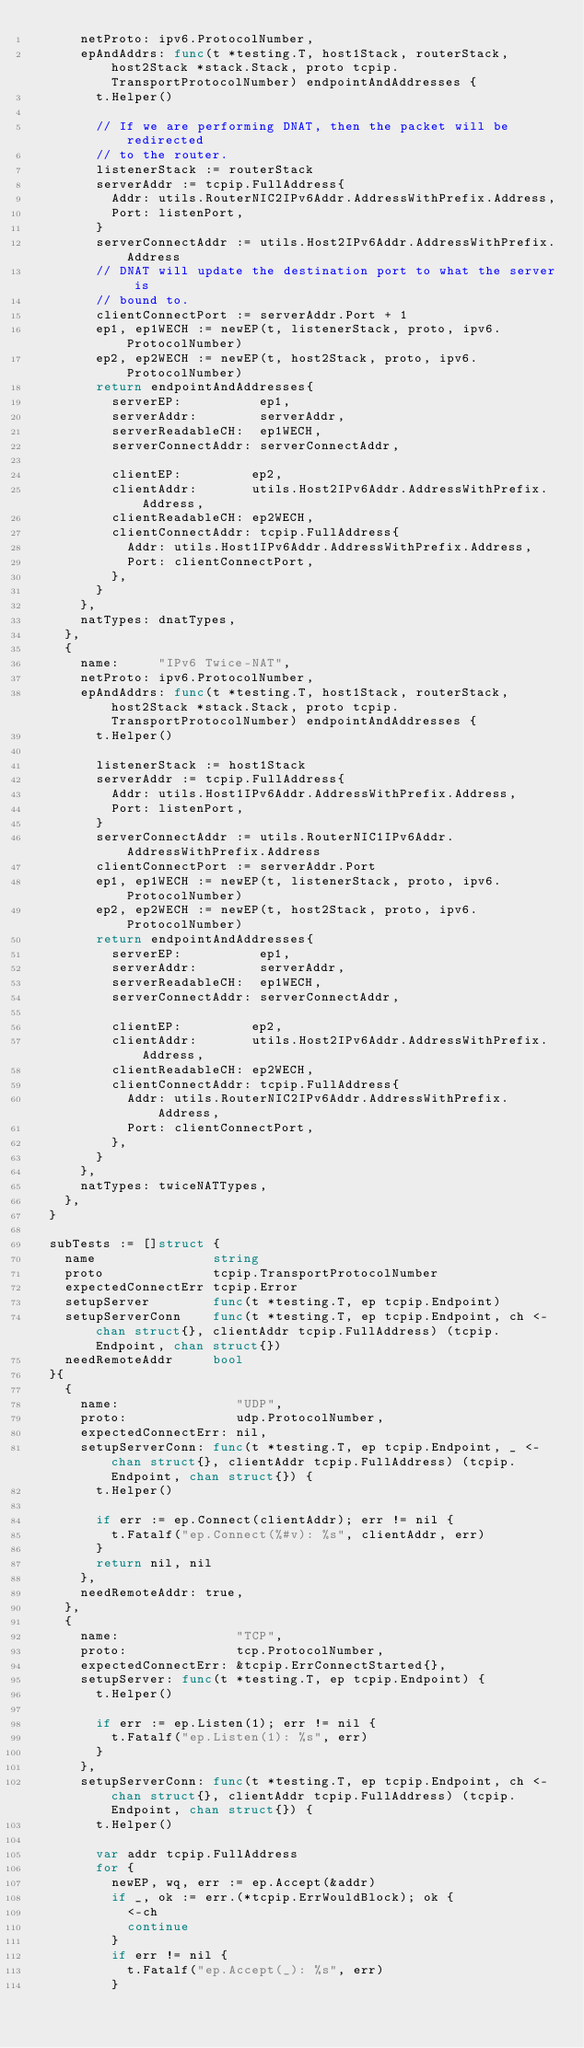<code> <loc_0><loc_0><loc_500><loc_500><_Go_>			netProto: ipv6.ProtocolNumber,
			epAndAddrs: func(t *testing.T, host1Stack, routerStack, host2Stack *stack.Stack, proto tcpip.TransportProtocolNumber) endpointAndAddresses {
				t.Helper()

				// If we are performing DNAT, then the packet will be redirected
				// to the router.
				listenerStack := routerStack
				serverAddr := tcpip.FullAddress{
					Addr: utils.RouterNIC2IPv6Addr.AddressWithPrefix.Address,
					Port: listenPort,
				}
				serverConnectAddr := utils.Host2IPv6Addr.AddressWithPrefix.Address
				// DNAT will update the destination port to what the server is
				// bound to.
				clientConnectPort := serverAddr.Port + 1
				ep1, ep1WECH := newEP(t, listenerStack, proto, ipv6.ProtocolNumber)
				ep2, ep2WECH := newEP(t, host2Stack, proto, ipv6.ProtocolNumber)
				return endpointAndAddresses{
					serverEP:          ep1,
					serverAddr:        serverAddr,
					serverReadableCH:  ep1WECH,
					serverConnectAddr: serverConnectAddr,

					clientEP:         ep2,
					clientAddr:       utils.Host2IPv6Addr.AddressWithPrefix.Address,
					clientReadableCH: ep2WECH,
					clientConnectAddr: tcpip.FullAddress{
						Addr: utils.Host1IPv6Addr.AddressWithPrefix.Address,
						Port: clientConnectPort,
					},
				}
			},
			natTypes: dnatTypes,
		},
		{
			name:     "IPv6 Twice-NAT",
			netProto: ipv6.ProtocolNumber,
			epAndAddrs: func(t *testing.T, host1Stack, routerStack, host2Stack *stack.Stack, proto tcpip.TransportProtocolNumber) endpointAndAddresses {
				t.Helper()

				listenerStack := host1Stack
				serverAddr := tcpip.FullAddress{
					Addr: utils.Host1IPv6Addr.AddressWithPrefix.Address,
					Port: listenPort,
				}
				serverConnectAddr := utils.RouterNIC1IPv6Addr.AddressWithPrefix.Address
				clientConnectPort := serverAddr.Port
				ep1, ep1WECH := newEP(t, listenerStack, proto, ipv6.ProtocolNumber)
				ep2, ep2WECH := newEP(t, host2Stack, proto, ipv6.ProtocolNumber)
				return endpointAndAddresses{
					serverEP:          ep1,
					serverAddr:        serverAddr,
					serverReadableCH:  ep1WECH,
					serverConnectAddr: serverConnectAddr,

					clientEP:         ep2,
					clientAddr:       utils.Host2IPv6Addr.AddressWithPrefix.Address,
					clientReadableCH: ep2WECH,
					clientConnectAddr: tcpip.FullAddress{
						Addr: utils.RouterNIC2IPv6Addr.AddressWithPrefix.Address,
						Port: clientConnectPort,
					},
				}
			},
			natTypes: twiceNATTypes,
		},
	}

	subTests := []struct {
		name               string
		proto              tcpip.TransportProtocolNumber
		expectedConnectErr tcpip.Error
		setupServer        func(t *testing.T, ep tcpip.Endpoint)
		setupServerConn    func(t *testing.T, ep tcpip.Endpoint, ch <-chan struct{}, clientAddr tcpip.FullAddress) (tcpip.Endpoint, chan struct{})
		needRemoteAddr     bool
	}{
		{
			name:               "UDP",
			proto:              udp.ProtocolNumber,
			expectedConnectErr: nil,
			setupServerConn: func(t *testing.T, ep tcpip.Endpoint, _ <-chan struct{}, clientAddr tcpip.FullAddress) (tcpip.Endpoint, chan struct{}) {
				t.Helper()

				if err := ep.Connect(clientAddr); err != nil {
					t.Fatalf("ep.Connect(%#v): %s", clientAddr, err)
				}
				return nil, nil
			},
			needRemoteAddr: true,
		},
		{
			name:               "TCP",
			proto:              tcp.ProtocolNumber,
			expectedConnectErr: &tcpip.ErrConnectStarted{},
			setupServer: func(t *testing.T, ep tcpip.Endpoint) {
				t.Helper()

				if err := ep.Listen(1); err != nil {
					t.Fatalf("ep.Listen(1): %s", err)
				}
			},
			setupServerConn: func(t *testing.T, ep tcpip.Endpoint, ch <-chan struct{}, clientAddr tcpip.FullAddress) (tcpip.Endpoint, chan struct{}) {
				t.Helper()

				var addr tcpip.FullAddress
				for {
					newEP, wq, err := ep.Accept(&addr)
					if _, ok := err.(*tcpip.ErrWouldBlock); ok {
						<-ch
						continue
					}
					if err != nil {
						t.Fatalf("ep.Accept(_): %s", err)
					}</code> 